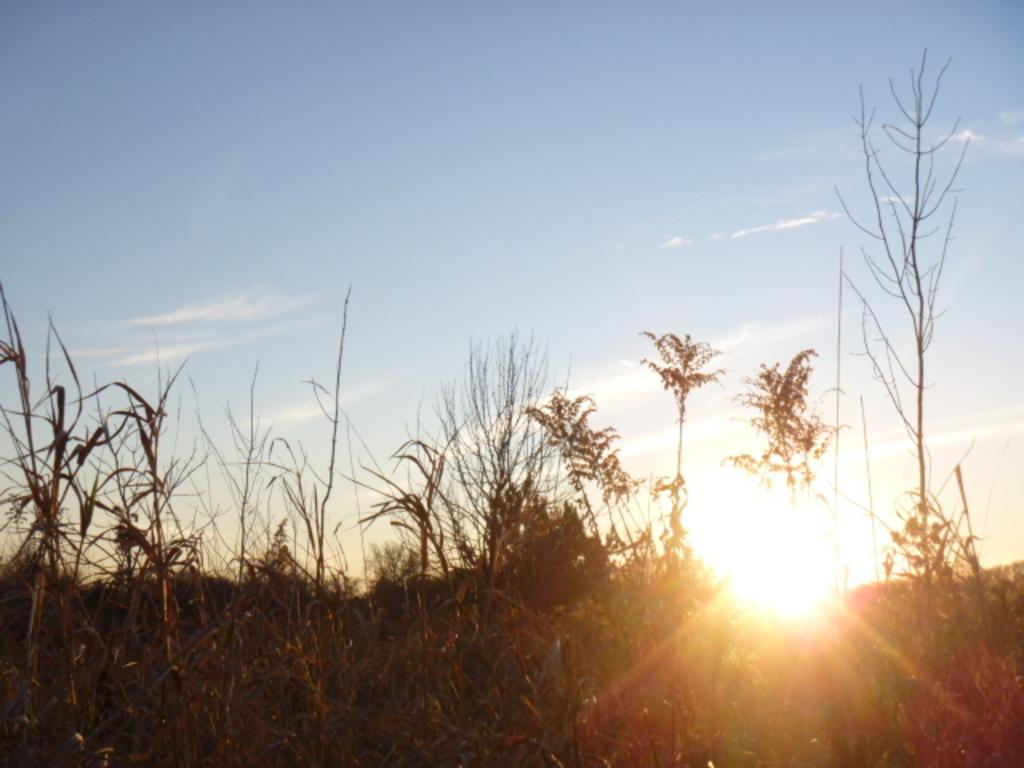What celestial bodies are present in the image? There are planets in the image. What type of terrestrial objects can be seen in the image? There are trees in the image. What can be seen in the background of the image? The sky is visible in the background of the image. Where is the crate located in the image? There is no crate present in the image. Can you see the dad in the image? There is no dad or any human figure present in the image. 